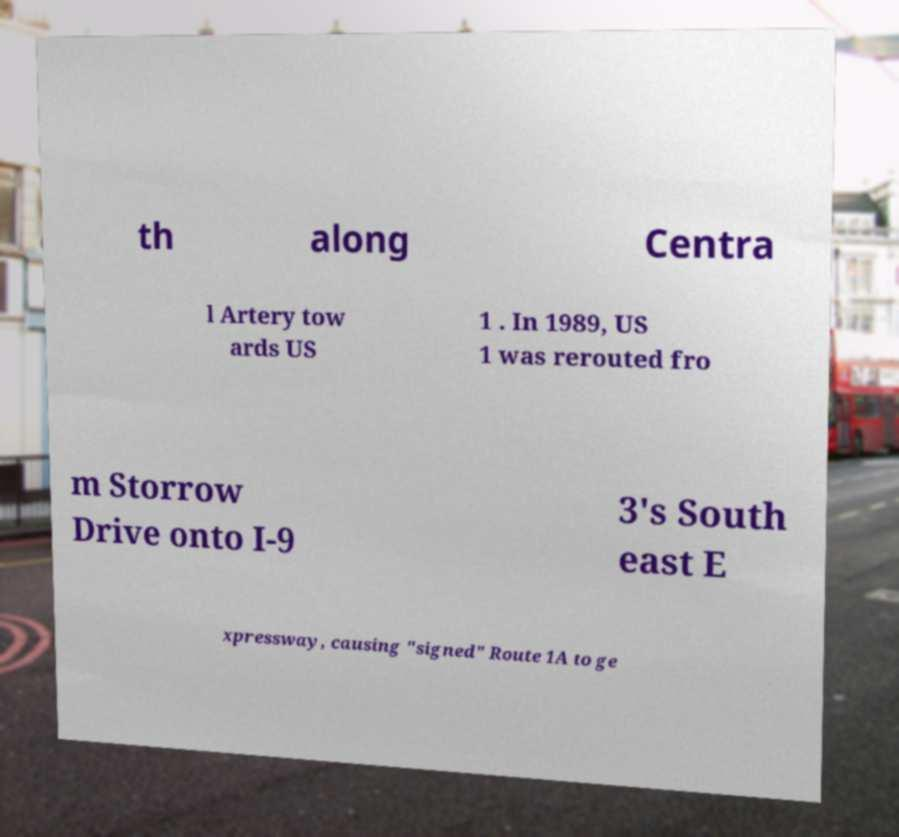There's text embedded in this image that I need extracted. Can you transcribe it verbatim? th along Centra l Artery tow ards US 1 . In 1989, US 1 was rerouted fro m Storrow Drive onto I-9 3's South east E xpressway, causing "signed" Route 1A to ge 